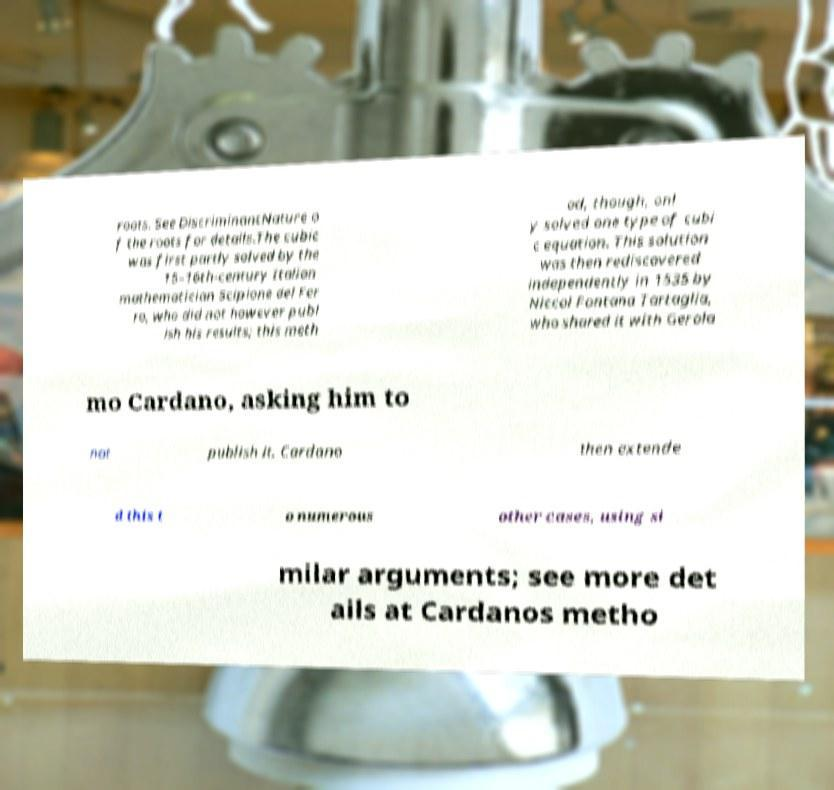Could you extract and type out the text from this image? roots. See DiscriminantNature o f the roots for details.The cubic was first partly solved by the 15–16th-century Italian mathematician Scipione del Fer ro, who did not however publ ish his results; this meth od, though, onl y solved one type of cubi c equation. This solution was then rediscovered independently in 1535 by Niccol Fontana Tartaglia, who shared it with Gerola mo Cardano, asking him to not publish it. Cardano then extende d this t o numerous other cases, using si milar arguments; see more det ails at Cardanos metho 